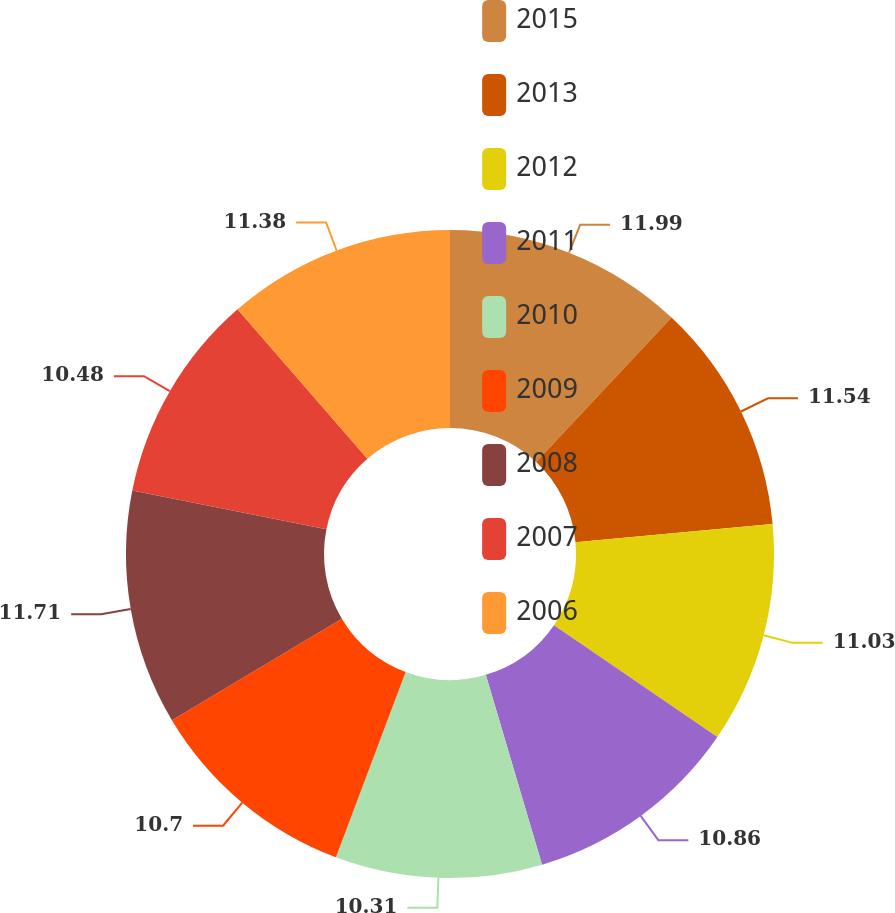<chart> <loc_0><loc_0><loc_500><loc_500><pie_chart><fcel>2015<fcel>2013<fcel>2012<fcel>2011<fcel>2010<fcel>2009<fcel>2008<fcel>2007<fcel>2006<nl><fcel>11.98%<fcel>11.54%<fcel>11.03%<fcel>10.86%<fcel>10.31%<fcel>10.7%<fcel>11.71%<fcel>10.48%<fcel>11.38%<nl></chart> 